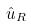<formula> <loc_0><loc_0><loc_500><loc_500>\hat { u } _ { R }</formula> 